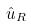<formula> <loc_0><loc_0><loc_500><loc_500>\hat { u } _ { R }</formula> 